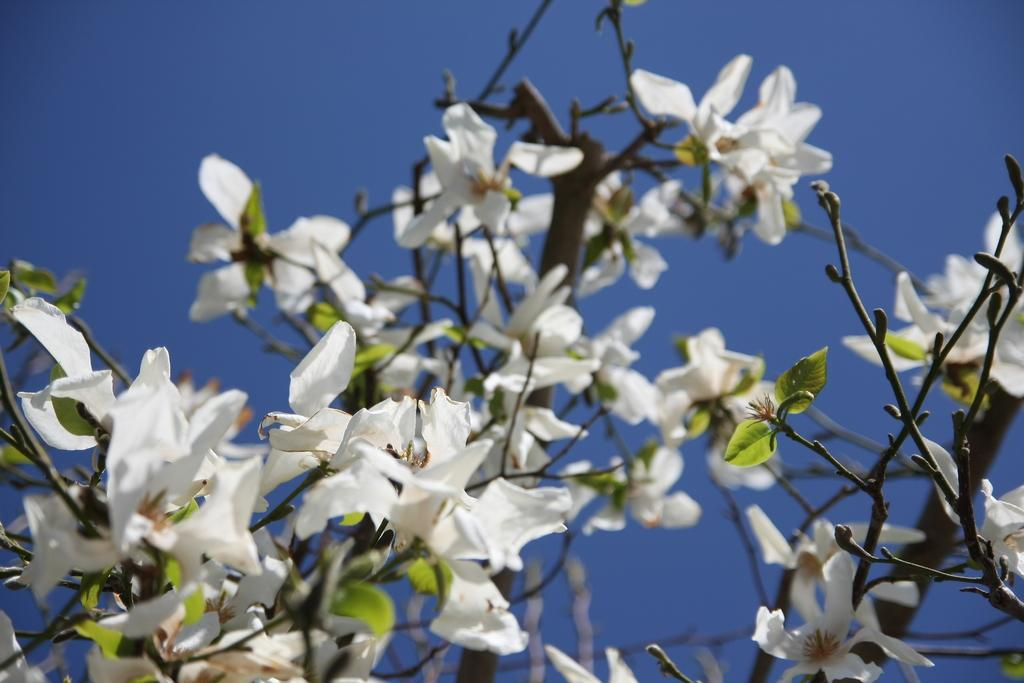What type of plant is visible in the image? There is a flower plant in the image. What color is the sky in the image? The sky is blue in the image. What type of meat is being cooked on the grill in the image? There is no grill or meat present in the image; it only features a flower plant and a blue sky. 